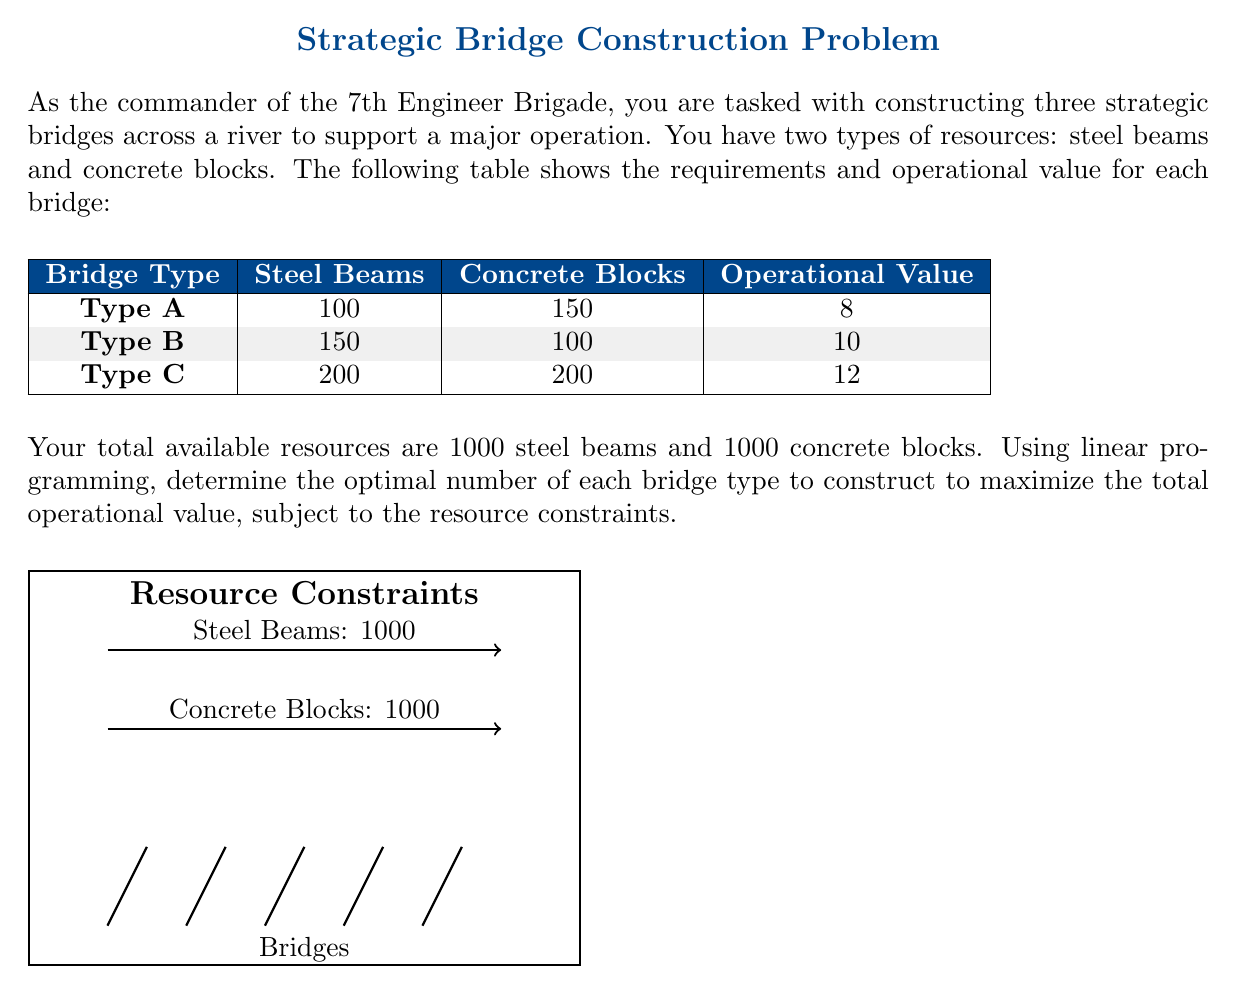Solve this math problem. Let's solve this problem step-by-step using linear programming:

1) Define variables:
   Let $x$, $y$, and $z$ be the number of Type A, B, and C bridges, respectively.

2) Objective function:
   Maximize $8x + 10y + 12z$ (total operational value)

3) Constraints:
   Steel beam constraint: $100x + 150y + 200z \leq 1000$
   Concrete block constraint: $150x + 100y + 200z \leq 1000$
   Non-negativity: $x, y, z \geq 0$

4) Solve using the simplex method or a linear programming solver. We'll outline the key steps:

   a) Convert to standard form by adding slack variables:
      $100x + 150y + 200z + s_1 = 1000$
      $150x + 100y + 200z + s_2 = 1000$
      Maximize $8x + 10y + 12z + 0s_1 + 0s_2$

   b) Initial tableau:
      $$
      \begin{array}{c|cccccc}
        & x & y & z & s_1 & s_2 & RHS \\
      \hline
      s_1 & 100 & 150 & 200 & 1 & 0 & 1000 \\
      s_2 & 150 & 100 & 200 & 0 & 1 & 1000 \\
      \hline
      -z & -8 & -10 & -12 & 0 & 0 & 0
      \end{array}
      $$

   c) After pivoting operations, we reach the optimal tableau:
      $$
      \begin{array}{c|cccccc}
        & x & y & z & s_1 & s_2 & RHS \\
      \hline
      x & 1 & 0 & 0 & 1/50 & -1/50 & 5 \\
      y & 0 & 1 & 0 & -1/25 & 1/25 & 5 \\
      \hline
      -z & 0 & 0 & 0 & 1/5 & 1/5 & -90
      \end{array}
      $$

5) Interpret the results:
   Optimal solution: $x = 5$, $y = 5$, $z = 0$
   Maximum operational value: 90

This means the optimal allocation is to construct 5 Type A bridges and 5 Type B bridges, resulting in a total operational value of 90.
Answer: 5 Type A bridges, 5 Type B bridges, 0 Type C bridges; Maximum operational value: 90 